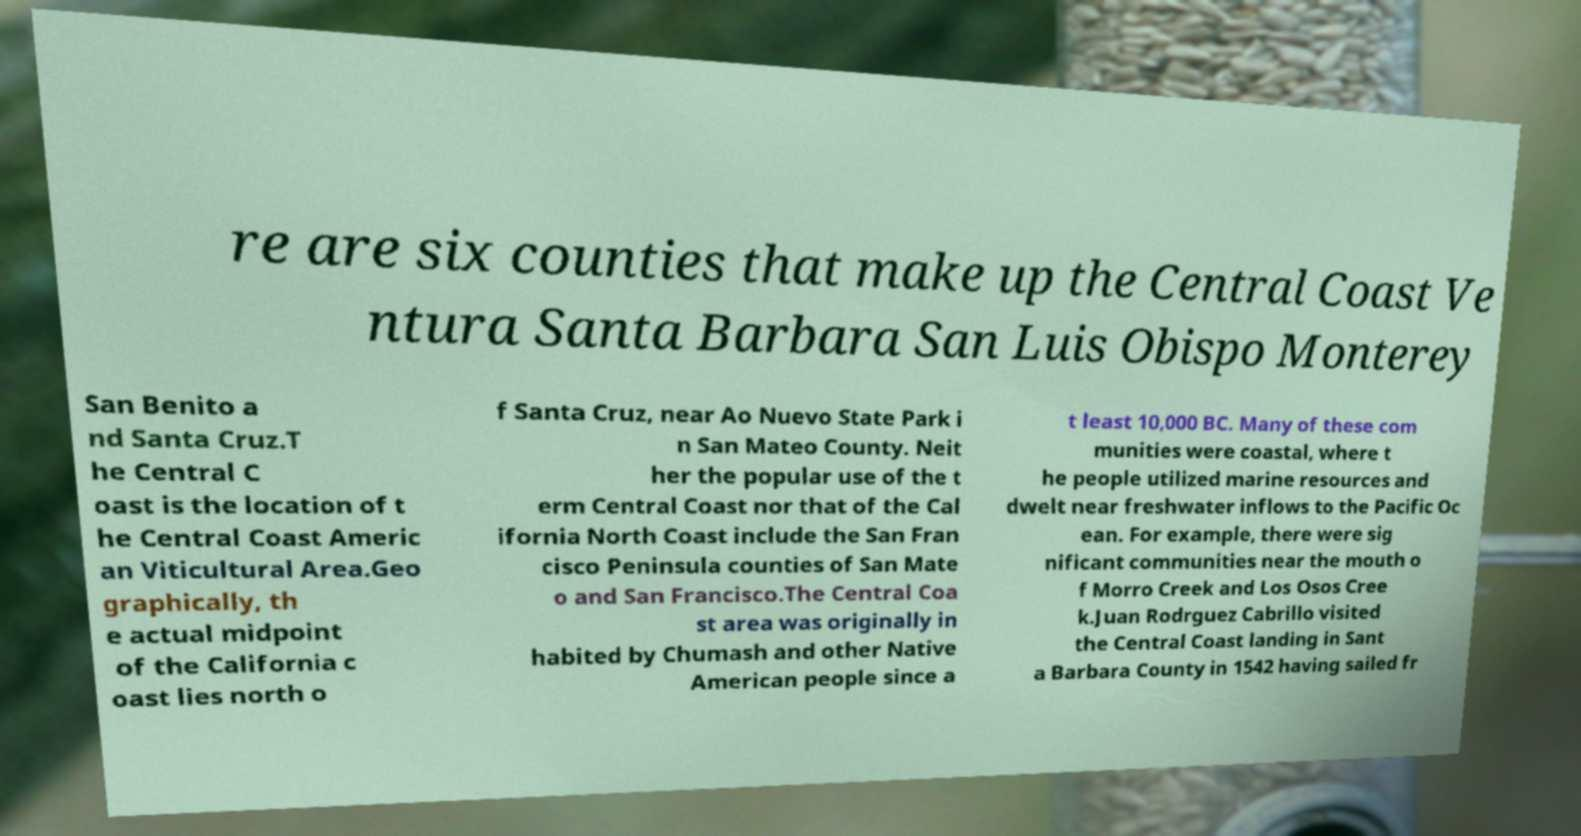Can you read and provide the text displayed in the image?This photo seems to have some interesting text. Can you extract and type it out for me? re are six counties that make up the Central Coast Ve ntura Santa Barbara San Luis Obispo Monterey San Benito a nd Santa Cruz.T he Central C oast is the location of t he Central Coast Americ an Viticultural Area.Geo graphically, th e actual midpoint of the California c oast lies north o f Santa Cruz, near Ao Nuevo State Park i n San Mateo County. Neit her the popular use of the t erm Central Coast nor that of the Cal ifornia North Coast include the San Fran cisco Peninsula counties of San Mate o and San Francisco.The Central Coa st area was originally in habited by Chumash and other Native American people since a t least 10,000 BC. Many of these com munities were coastal, where t he people utilized marine resources and dwelt near freshwater inflows to the Pacific Oc ean. For example, there were sig nificant communities near the mouth o f Morro Creek and Los Osos Cree k.Juan Rodrguez Cabrillo visited the Central Coast landing in Sant a Barbara County in 1542 having sailed fr 